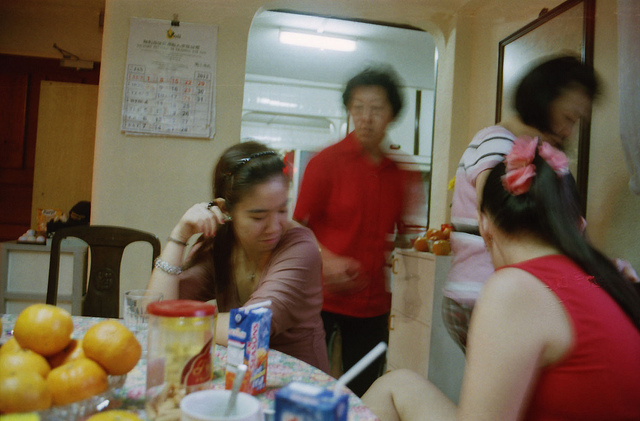<image>What brand orange juice? It is unknown what the brand of the orange juice is. Possible brands can be Nestle, Carnation, Dole, Sunkist or Tropicana. It's also possible that there is no orange juice in the image. Is this woman blowing her nose, caught in food, or trying to hide? I don't know if the woman is blowing her nose, caught in food, or trying to hide. However, it can be seen that she is trying to hide. Is this woman blowing her nose, caught in food, or trying to hide? It is ambiguous whether the woman is blowing her nose, caught in food, or trying to hide. What brand orange juice? I am not sure what brand of orange juice it is. It can be any of ['nestle', 'carnation', 'dole', 'sunkist', 'tropicana']. 